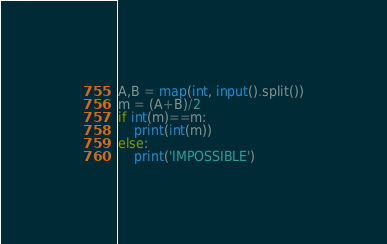<code> <loc_0><loc_0><loc_500><loc_500><_Python_>A,B = map(int, input().split())
m = (A+B)/2
if int(m)==m:
    print(int(m))
else:
    print('IMPOSSIBLE')</code> 